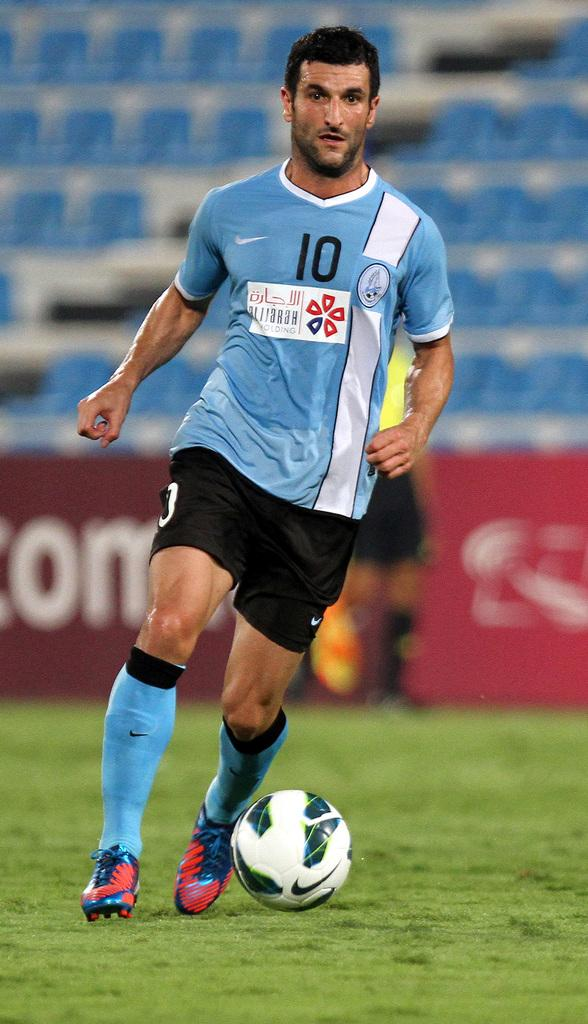<image>
Relay a brief, clear account of the picture shown. A player wearing number 10 dribbles the ball in the field. 